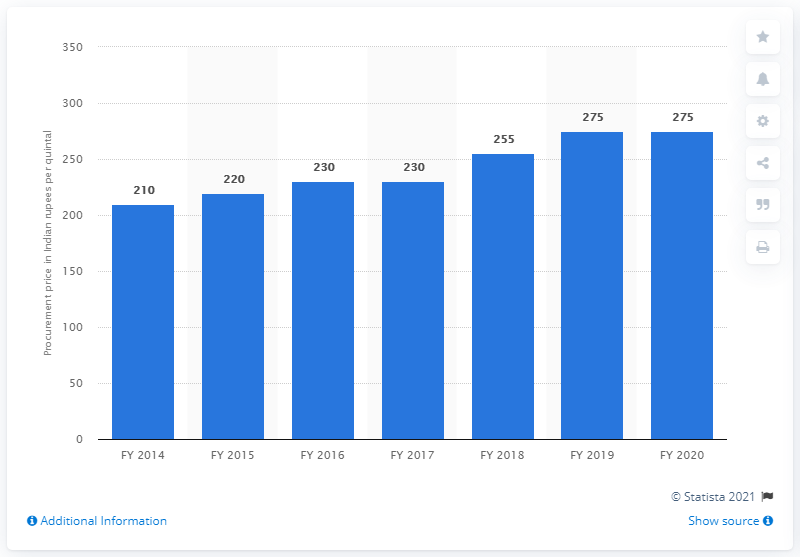Identify some key points in this picture. The procurement price of sugarcane in India during fiscal year 2020 was 275. 